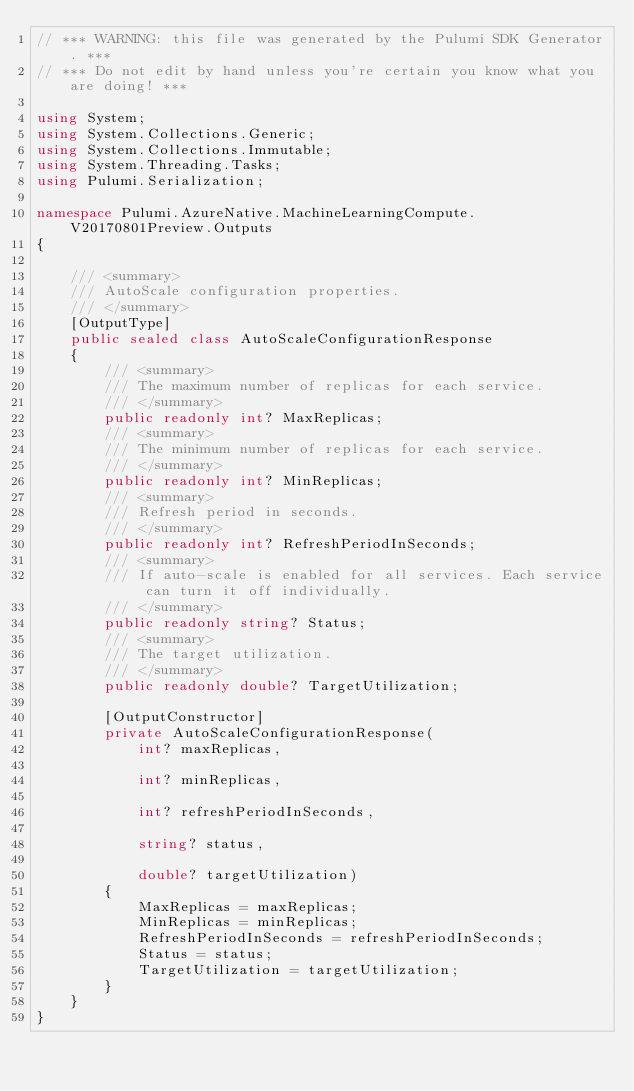Convert code to text. <code><loc_0><loc_0><loc_500><loc_500><_C#_>// *** WARNING: this file was generated by the Pulumi SDK Generator. ***
// *** Do not edit by hand unless you're certain you know what you are doing! ***

using System;
using System.Collections.Generic;
using System.Collections.Immutable;
using System.Threading.Tasks;
using Pulumi.Serialization;

namespace Pulumi.AzureNative.MachineLearningCompute.V20170801Preview.Outputs
{

    /// <summary>
    /// AutoScale configuration properties.
    /// </summary>
    [OutputType]
    public sealed class AutoScaleConfigurationResponse
    {
        /// <summary>
        /// The maximum number of replicas for each service.
        /// </summary>
        public readonly int? MaxReplicas;
        /// <summary>
        /// The minimum number of replicas for each service.
        /// </summary>
        public readonly int? MinReplicas;
        /// <summary>
        /// Refresh period in seconds.
        /// </summary>
        public readonly int? RefreshPeriodInSeconds;
        /// <summary>
        /// If auto-scale is enabled for all services. Each service can turn it off individually.
        /// </summary>
        public readonly string? Status;
        /// <summary>
        /// The target utilization.
        /// </summary>
        public readonly double? TargetUtilization;

        [OutputConstructor]
        private AutoScaleConfigurationResponse(
            int? maxReplicas,

            int? minReplicas,

            int? refreshPeriodInSeconds,

            string? status,

            double? targetUtilization)
        {
            MaxReplicas = maxReplicas;
            MinReplicas = minReplicas;
            RefreshPeriodInSeconds = refreshPeriodInSeconds;
            Status = status;
            TargetUtilization = targetUtilization;
        }
    }
}
</code> 